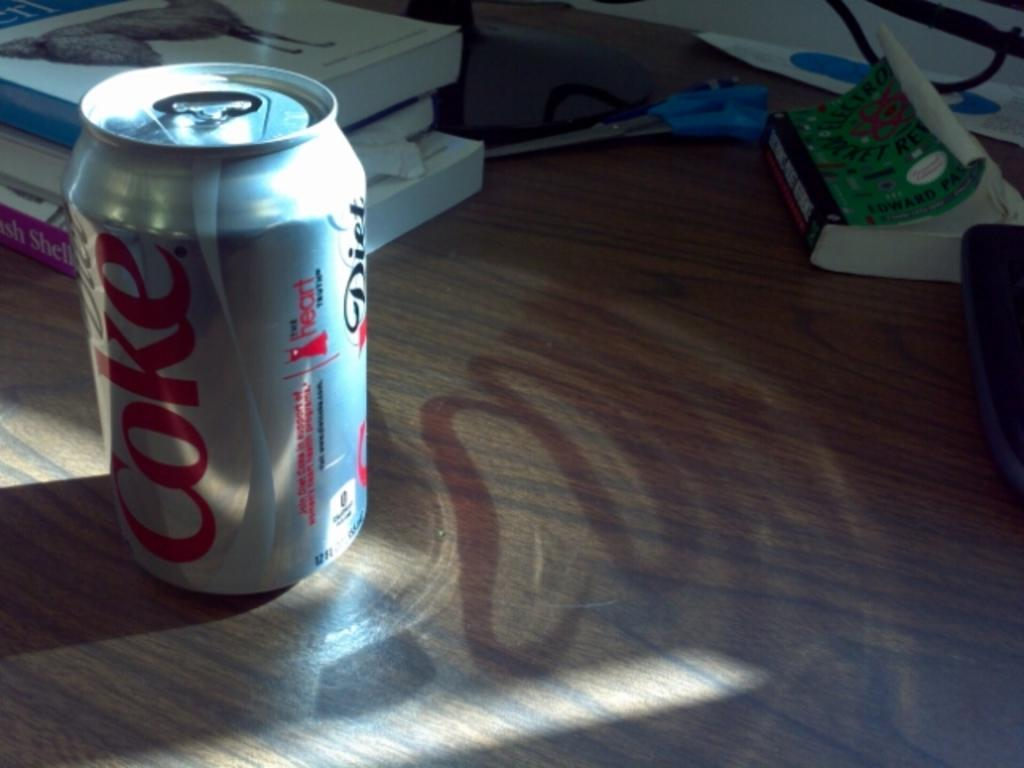<image>
Describe the image concisely. A can of Diet Coke sitting on a wooden desk. 